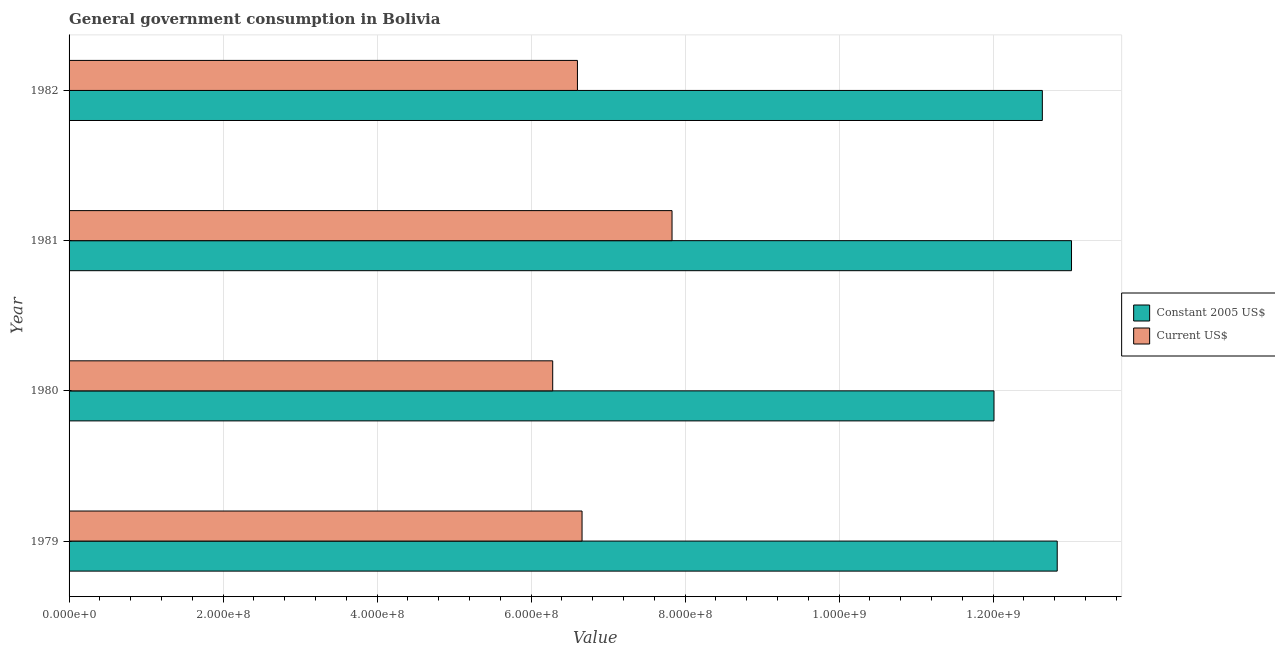How many different coloured bars are there?
Your answer should be very brief. 2. Are the number of bars on each tick of the Y-axis equal?
Provide a succinct answer. Yes. How many bars are there on the 4th tick from the top?
Ensure brevity in your answer.  2. How many bars are there on the 2nd tick from the bottom?
Offer a terse response. 2. What is the label of the 2nd group of bars from the top?
Give a very brief answer. 1981. What is the value consumed in current us$ in 1979?
Your answer should be very brief. 6.66e+08. Across all years, what is the maximum value consumed in current us$?
Provide a succinct answer. 7.83e+08. Across all years, what is the minimum value consumed in current us$?
Ensure brevity in your answer.  6.28e+08. In which year was the value consumed in constant 2005 us$ maximum?
Your answer should be compact. 1981. In which year was the value consumed in constant 2005 us$ minimum?
Make the answer very short. 1980. What is the total value consumed in constant 2005 us$ in the graph?
Your answer should be very brief. 5.05e+09. What is the difference between the value consumed in constant 2005 us$ in 1979 and that in 1982?
Your response must be concise. 1.93e+07. What is the difference between the value consumed in current us$ in 1979 and the value consumed in constant 2005 us$ in 1980?
Keep it short and to the point. -5.35e+08. What is the average value consumed in current us$ per year?
Provide a succinct answer. 6.84e+08. In the year 1981, what is the difference between the value consumed in constant 2005 us$ and value consumed in current us$?
Make the answer very short. 5.19e+08. In how many years, is the value consumed in current us$ greater than 1280000000 ?
Give a very brief answer. 0. What is the ratio of the value consumed in constant 2005 us$ in 1979 to that in 1980?
Make the answer very short. 1.07. Is the value consumed in current us$ in 1980 less than that in 1981?
Make the answer very short. Yes. Is the difference between the value consumed in current us$ in 1980 and 1981 greater than the difference between the value consumed in constant 2005 us$ in 1980 and 1981?
Offer a terse response. No. What is the difference between the highest and the second highest value consumed in constant 2005 us$?
Give a very brief answer. 1.86e+07. What is the difference between the highest and the lowest value consumed in constant 2005 us$?
Give a very brief answer. 1.01e+08. In how many years, is the value consumed in current us$ greater than the average value consumed in current us$ taken over all years?
Make the answer very short. 1. What does the 1st bar from the top in 1981 represents?
Give a very brief answer. Current US$. What does the 2nd bar from the bottom in 1980 represents?
Provide a short and direct response. Current US$. What is the difference between two consecutive major ticks on the X-axis?
Your answer should be very brief. 2.00e+08. Does the graph contain any zero values?
Your answer should be compact. No. How many legend labels are there?
Make the answer very short. 2. How are the legend labels stacked?
Your answer should be very brief. Vertical. What is the title of the graph?
Your response must be concise. General government consumption in Bolivia. Does "All education staff compensation" appear as one of the legend labels in the graph?
Your answer should be very brief. No. What is the label or title of the X-axis?
Your answer should be very brief. Value. What is the Value of Constant 2005 US$ in 1979?
Provide a short and direct response. 1.28e+09. What is the Value in Current US$ in 1979?
Offer a very short reply. 6.66e+08. What is the Value of Constant 2005 US$ in 1980?
Offer a terse response. 1.20e+09. What is the Value of Current US$ in 1980?
Ensure brevity in your answer.  6.28e+08. What is the Value in Constant 2005 US$ in 1981?
Make the answer very short. 1.30e+09. What is the Value of Current US$ in 1981?
Make the answer very short. 7.83e+08. What is the Value in Constant 2005 US$ in 1982?
Offer a terse response. 1.26e+09. What is the Value in Current US$ in 1982?
Provide a succinct answer. 6.60e+08. Across all years, what is the maximum Value in Constant 2005 US$?
Your answer should be very brief. 1.30e+09. Across all years, what is the maximum Value of Current US$?
Make the answer very short. 7.83e+08. Across all years, what is the minimum Value in Constant 2005 US$?
Your answer should be compact. 1.20e+09. Across all years, what is the minimum Value of Current US$?
Give a very brief answer. 6.28e+08. What is the total Value in Constant 2005 US$ in the graph?
Provide a succinct answer. 5.05e+09. What is the total Value of Current US$ in the graph?
Make the answer very short. 2.74e+09. What is the difference between the Value of Constant 2005 US$ in 1979 and that in 1980?
Your answer should be very brief. 8.21e+07. What is the difference between the Value in Current US$ in 1979 and that in 1980?
Offer a terse response. 3.81e+07. What is the difference between the Value of Constant 2005 US$ in 1979 and that in 1981?
Keep it short and to the point. -1.86e+07. What is the difference between the Value of Current US$ in 1979 and that in 1981?
Provide a succinct answer. -1.17e+08. What is the difference between the Value of Constant 2005 US$ in 1979 and that in 1982?
Make the answer very short. 1.93e+07. What is the difference between the Value of Current US$ in 1979 and that in 1982?
Your answer should be very brief. 5.97e+06. What is the difference between the Value of Constant 2005 US$ in 1980 and that in 1981?
Keep it short and to the point. -1.01e+08. What is the difference between the Value in Current US$ in 1980 and that in 1981?
Your answer should be compact. -1.55e+08. What is the difference between the Value in Constant 2005 US$ in 1980 and that in 1982?
Your response must be concise. -6.28e+07. What is the difference between the Value of Current US$ in 1980 and that in 1982?
Ensure brevity in your answer.  -3.21e+07. What is the difference between the Value of Constant 2005 US$ in 1981 and that in 1982?
Ensure brevity in your answer.  3.79e+07. What is the difference between the Value in Current US$ in 1981 and that in 1982?
Your answer should be very brief. 1.23e+08. What is the difference between the Value of Constant 2005 US$ in 1979 and the Value of Current US$ in 1980?
Provide a succinct answer. 6.55e+08. What is the difference between the Value in Constant 2005 US$ in 1979 and the Value in Current US$ in 1981?
Give a very brief answer. 5.00e+08. What is the difference between the Value in Constant 2005 US$ in 1979 and the Value in Current US$ in 1982?
Provide a short and direct response. 6.23e+08. What is the difference between the Value of Constant 2005 US$ in 1980 and the Value of Current US$ in 1981?
Give a very brief answer. 4.18e+08. What is the difference between the Value of Constant 2005 US$ in 1980 and the Value of Current US$ in 1982?
Offer a terse response. 5.41e+08. What is the difference between the Value in Constant 2005 US$ in 1981 and the Value in Current US$ in 1982?
Provide a short and direct response. 6.42e+08. What is the average Value in Constant 2005 US$ per year?
Make the answer very short. 1.26e+09. What is the average Value in Current US$ per year?
Give a very brief answer. 6.84e+08. In the year 1979, what is the difference between the Value in Constant 2005 US$ and Value in Current US$?
Offer a very short reply. 6.17e+08. In the year 1980, what is the difference between the Value of Constant 2005 US$ and Value of Current US$?
Ensure brevity in your answer.  5.73e+08. In the year 1981, what is the difference between the Value of Constant 2005 US$ and Value of Current US$?
Make the answer very short. 5.19e+08. In the year 1982, what is the difference between the Value of Constant 2005 US$ and Value of Current US$?
Your answer should be very brief. 6.04e+08. What is the ratio of the Value in Constant 2005 US$ in 1979 to that in 1980?
Ensure brevity in your answer.  1.07. What is the ratio of the Value of Current US$ in 1979 to that in 1980?
Offer a very short reply. 1.06. What is the ratio of the Value in Constant 2005 US$ in 1979 to that in 1981?
Give a very brief answer. 0.99. What is the ratio of the Value of Current US$ in 1979 to that in 1981?
Ensure brevity in your answer.  0.85. What is the ratio of the Value of Constant 2005 US$ in 1979 to that in 1982?
Make the answer very short. 1.02. What is the ratio of the Value of Constant 2005 US$ in 1980 to that in 1981?
Make the answer very short. 0.92. What is the ratio of the Value of Current US$ in 1980 to that in 1981?
Offer a very short reply. 0.8. What is the ratio of the Value of Constant 2005 US$ in 1980 to that in 1982?
Make the answer very short. 0.95. What is the ratio of the Value of Current US$ in 1980 to that in 1982?
Your response must be concise. 0.95. What is the ratio of the Value in Constant 2005 US$ in 1981 to that in 1982?
Your answer should be compact. 1.03. What is the ratio of the Value in Current US$ in 1981 to that in 1982?
Provide a short and direct response. 1.19. What is the difference between the highest and the second highest Value of Constant 2005 US$?
Give a very brief answer. 1.86e+07. What is the difference between the highest and the second highest Value in Current US$?
Give a very brief answer. 1.17e+08. What is the difference between the highest and the lowest Value in Constant 2005 US$?
Keep it short and to the point. 1.01e+08. What is the difference between the highest and the lowest Value in Current US$?
Offer a terse response. 1.55e+08. 